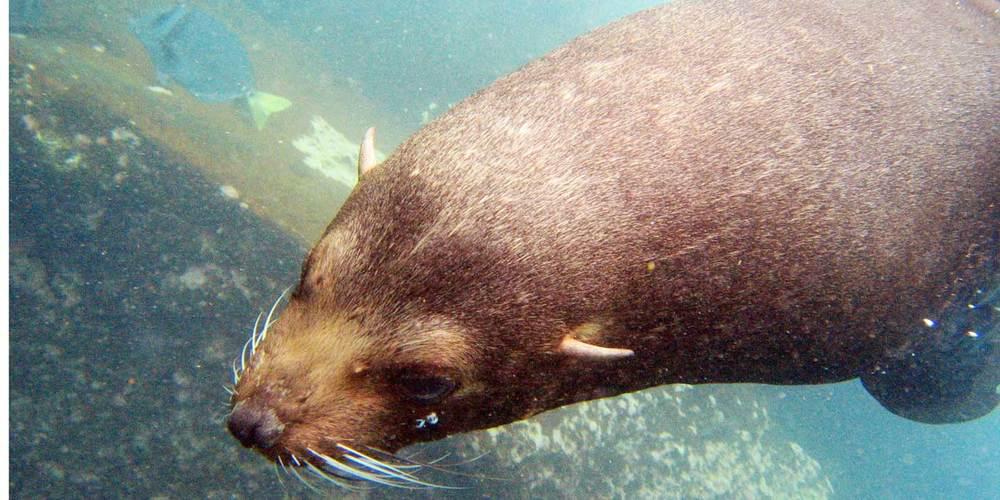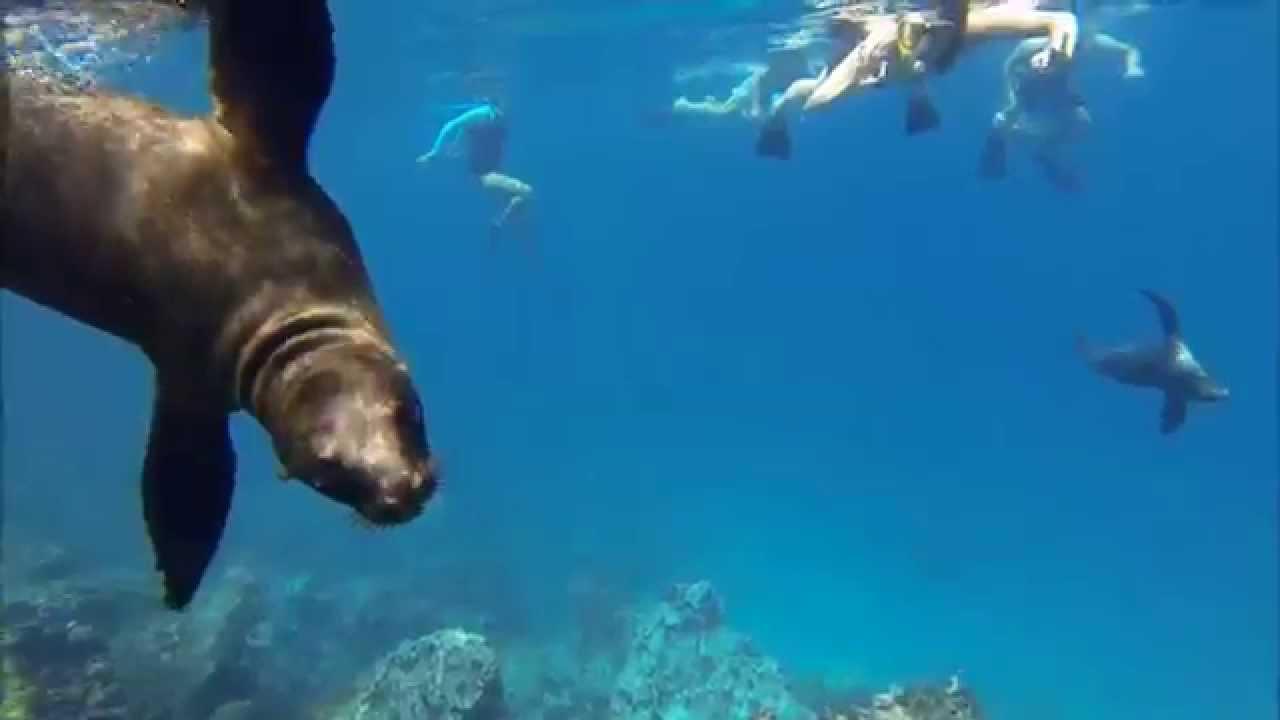The first image is the image on the left, the second image is the image on the right. Analyze the images presented: Is the assertion "The left image contains exactly two seals." valid? Answer yes or no. No. 